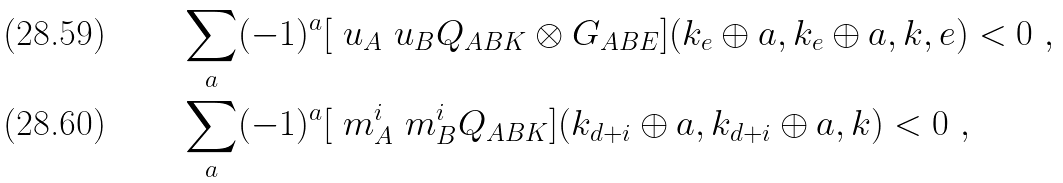<formula> <loc_0><loc_0><loc_500><loc_500>& \sum _ { a } ( - 1 ) ^ { a } [ \ u _ { A } \ u _ { B } Q _ { A B K } \otimes G _ { A B E } ] ( k _ { e } \oplus a , k _ { e } \oplus a , { k } , e ) < 0 \ , \\ & \sum _ { a } ( - 1 ) ^ { a } [ \ m ^ { i } _ { A } \ m ^ { i } _ { B } Q _ { A B K } ] ( k _ { d + i } \oplus a , k _ { d + i } \oplus a , { k } ) < 0 \ ,</formula> 